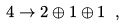<formula> <loc_0><loc_0><loc_500><loc_500>4 \to 2 \oplus 1 \oplus 1 \ ,</formula> 